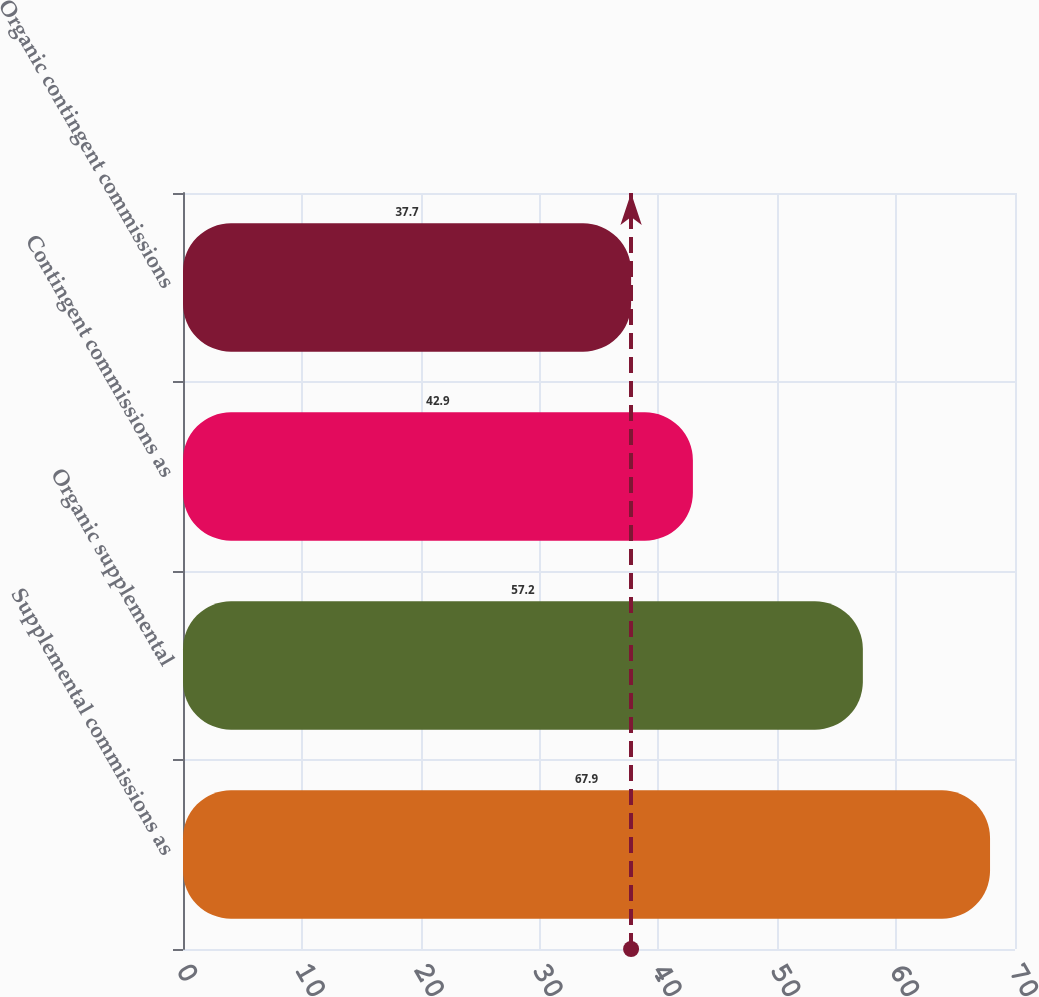<chart> <loc_0><loc_0><loc_500><loc_500><bar_chart><fcel>Supplemental commissions as<fcel>Organic supplemental<fcel>Contingent commissions as<fcel>Organic contingent commissions<nl><fcel>67.9<fcel>57.2<fcel>42.9<fcel>37.7<nl></chart> 